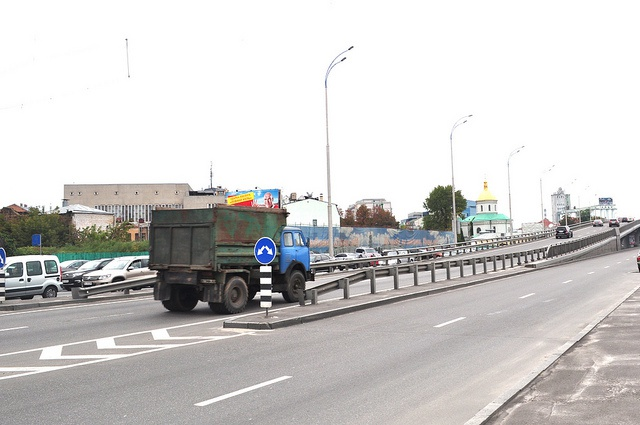Describe the objects in this image and their specific colors. I can see car in white, gray, black, and darkgray tones, truck in white, gray, and black tones, car in white, gray, black, and darkgray tones, car in white, darkgray, gray, and black tones, and car in white, gray, black, and darkgray tones in this image. 